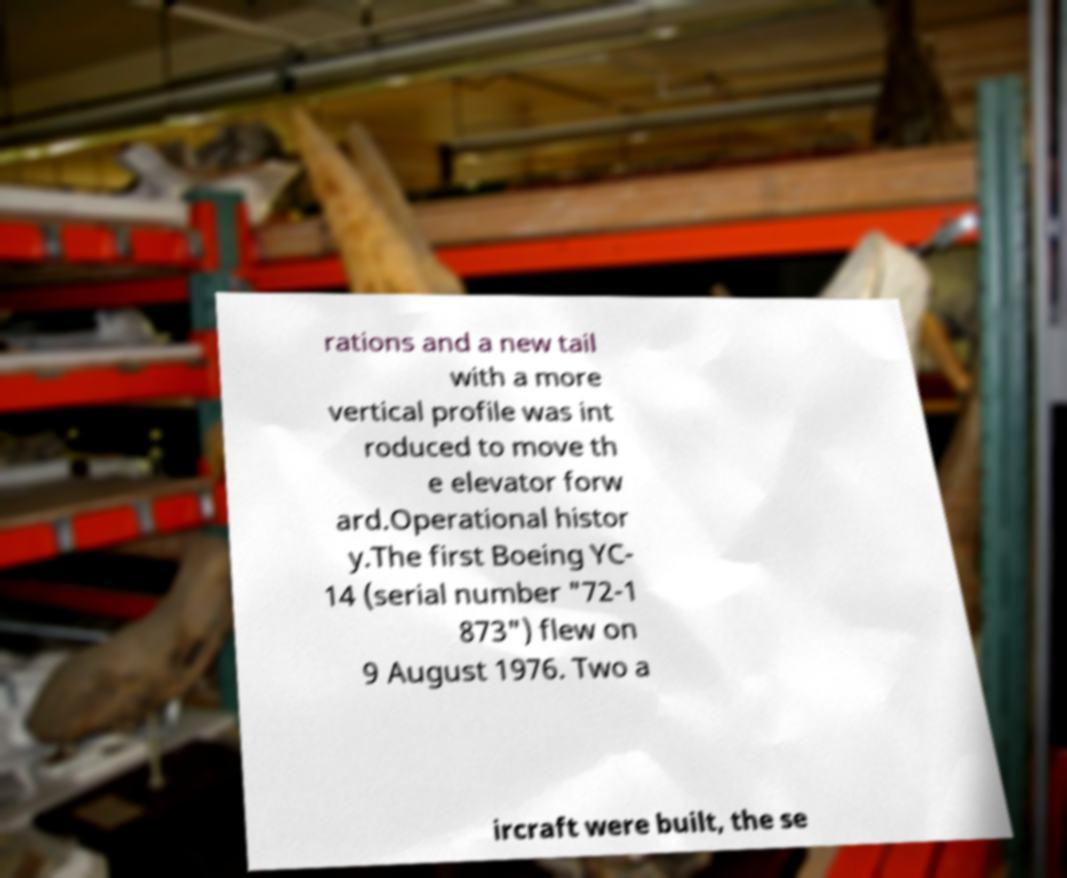Please read and relay the text visible in this image. What does it say? rations and a new tail with a more vertical profile was int roduced to move th e elevator forw ard.Operational histor y.The first Boeing YC- 14 (serial number "72-1 873") flew on 9 August 1976. Two a ircraft were built, the se 